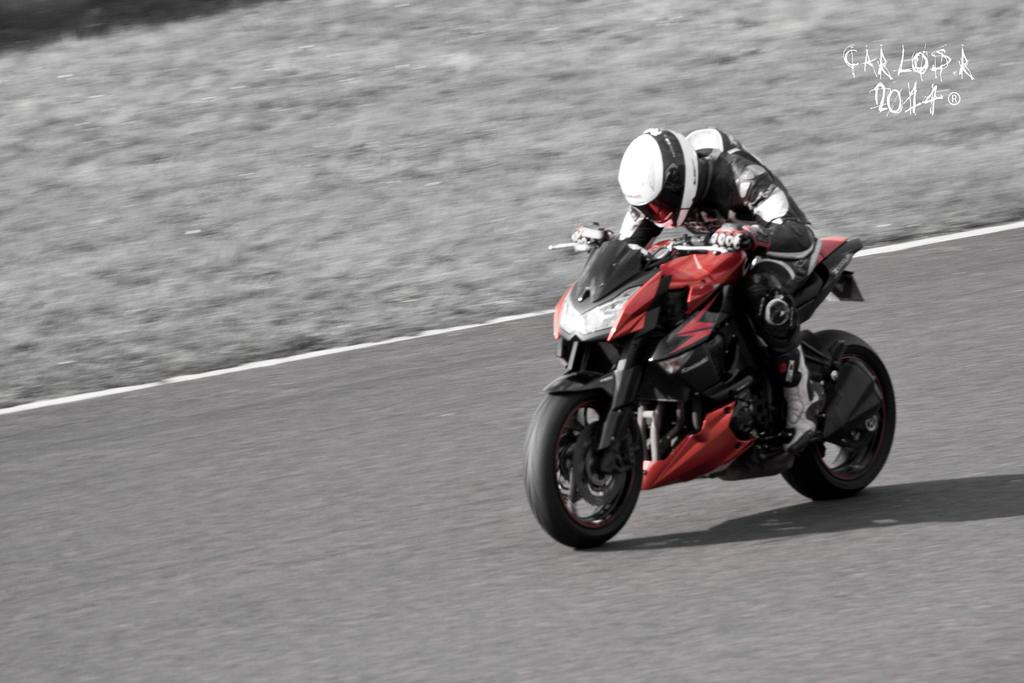What can be seen in the top right corner of the image? There is a watermark in the top right corner of the image. Who is present in the image? There is a man in the image. What protective gear is the man wearing? The man is wearing a helmet and gloves. What is the man doing in the image? The man is riding a motorbike. Where is the motorbike located in the image? The motorbike is on the road. What type of oatmeal is the man eating while riding the motorbike in the image? There is no oatmeal present in the image, and the man is not eating anything while riding the motorbike. What time of day is it in the image, based on the hour? The provided facts do not mention the time of day or any specific hour, so it cannot be determined from the image. 